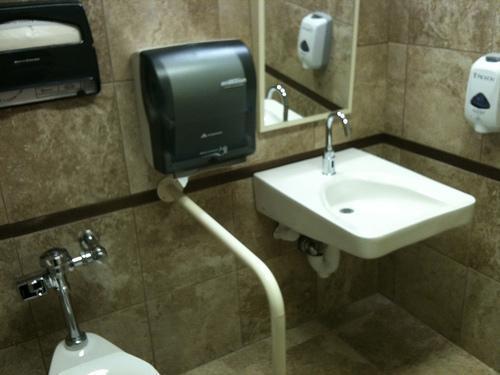How many sinks are in this picture?
Give a very brief answer. 1. How many soap dispensers are on the wall?
Give a very brief answer. 1. 